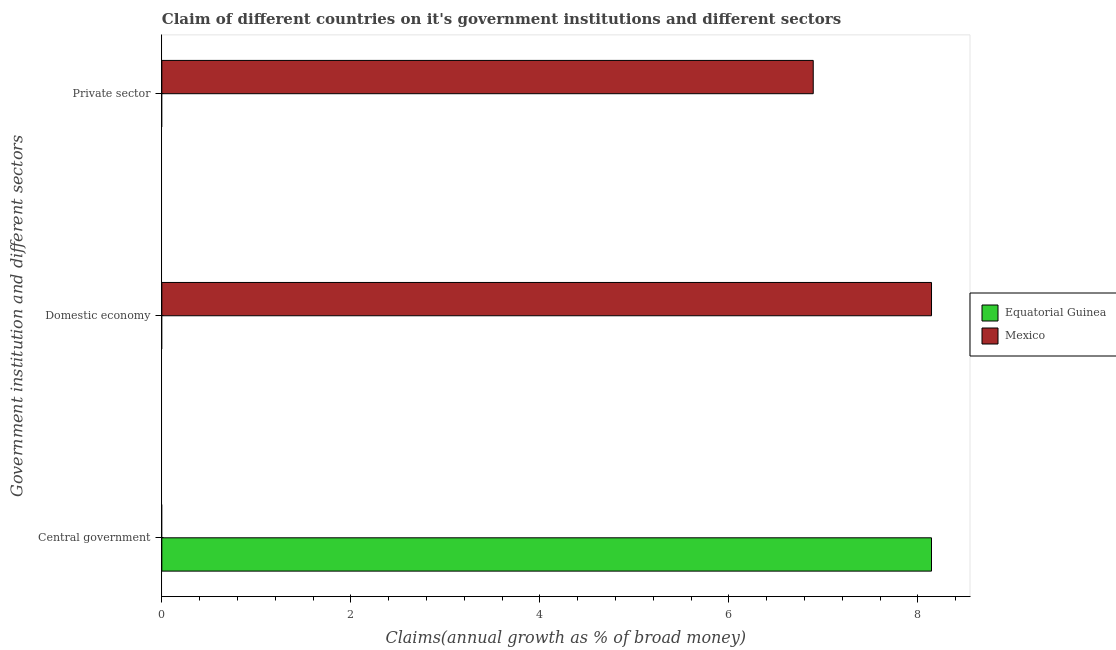Are the number of bars per tick equal to the number of legend labels?
Your answer should be compact. No. Are the number of bars on each tick of the Y-axis equal?
Provide a short and direct response. Yes. How many bars are there on the 1st tick from the bottom?
Keep it short and to the point. 1. What is the label of the 1st group of bars from the top?
Offer a terse response. Private sector. What is the percentage of claim on the central government in Equatorial Guinea?
Offer a very short reply. 8.14. Across all countries, what is the maximum percentage of claim on the private sector?
Your response must be concise. 6.89. Across all countries, what is the minimum percentage of claim on the domestic economy?
Ensure brevity in your answer.  0. What is the total percentage of claim on the domestic economy in the graph?
Your answer should be compact. 8.14. What is the difference between the percentage of claim on the private sector in Mexico and the percentage of claim on the central government in Equatorial Guinea?
Your answer should be compact. -1.25. What is the average percentage of claim on the central government per country?
Ensure brevity in your answer.  4.07. What is the difference between the percentage of claim on the private sector and percentage of claim on the domestic economy in Mexico?
Your answer should be very brief. -1.25. What is the difference between the highest and the lowest percentage of claim on the central government?
Provide a succinct answer. 8.14. Is it the case that in every country, the sum of the percentage of claim on the central government and percentage of claim on the domestic economy is greater than the percentage of claim on the private sector?
Your response must be concise. Yes. How many bars are there?
Offer a very short reply. 3. Are all the bars in the graph horizontal?
Offer a terse response. Yes. What is the difference between two consecutive major ticks on the X-axis?
Keep it short and to the point. 2. Are the values on the major ticks of X-axis written in scientific E-notation?
Your answer should be very brief. No. How many legend labels are there?
Your response must be concise. 2. What is the title of the graph?
Provide a short and direct response. Claim of different countries on it's government institutions and different sectors. Does "High income" appear as one of the legend labels in the graph?
Give a very brief answer. No. What is the label or title of the X-axis?
Your response must be concise. Claims(annual growth as % of broad money). What is the label or title of the Y-axis?
Your response must be concise. Government institution and different sectors. What is the Claims(annual growth as % of broad money) in Equatorial Guinea in Central government?
Offer a terse response. 8.14. What is the Claims(annual growth as % of broad money) of Mexico in Domestic economy?
Give a very brief answer. 8.14. What is the Claims(annual growth as % of broad money) in Equatorial Guinea in Private sector?
Make the answer very short. 0. What is the Claims(annual growth as % of broad money) of Mexico in Private sector?
Provide a short and direct response. 6.89. Across all Government institution and different sectors, what is the maximum Claims(annual growth as % of broad money) of Equatorial Guinea?
Your answer should be compact. 8.14. Across all Government institution and different sectors, what is the maximum Claims(annual growth as % of broad money) in Mexico?
Keep it short and to the point. 8.14. Across all Government institution and different sectors, what is the minimum Claims(annual growth as % of broad money) of Equatorial Guinea?
Keep it short and to the point. 0. What is the total Claims(annual growth as % of broad money) of Equatorial Guinea in the graph?
Your answer should be very brief. 8.14. What is the total Claims(annual growth as % of broad money) in Mexico in the graph?
Keep it short and to the point. 15.04. What is the difference between the Claims(annual growth as % of broad money) of Mexico in Domestic economy and that in Private sector?
Provide a succinct answer. 1.25. What is the difference between the Claims(annual growth as % of broad money) in Equatorial Guinea in Central government and the Claims(annual growth as % of broad money) in Mexico in Domestic economy?
Make the answer very short. -0. What is the difference between the Claims(annual growth as % of broad money) of Equatorial Guinea in Central government and the Claims(annual growth as % of broad money) of Mexico in Private sector?
Your response must be concise. 1.25. What is the average Claims(annual growth as % of broad money) in Equatorial Guinea per Government institution and different sectors?
Provide a succinct answer. 2.71. What is the average Claims(annual growth as % of broad money) in Mexico per Government institution and different sectors?
Your response must be concise. 5.01. What is the ratio of the Claims(annual growth as % of broad money) in Mexico in Domestic economy to that in Private sector?
Make the answer very short. 1.18. What is the difference between the highest and the lowest Claims(annual growth as % of broad money) of Equatorial Guinea?
Ensure brevity in your answer.  8.14. What is the difference between the highest and the lowest Claims(annual growth as % of broad money) of Mexico?
Provide a short and direct response. 8.14. 